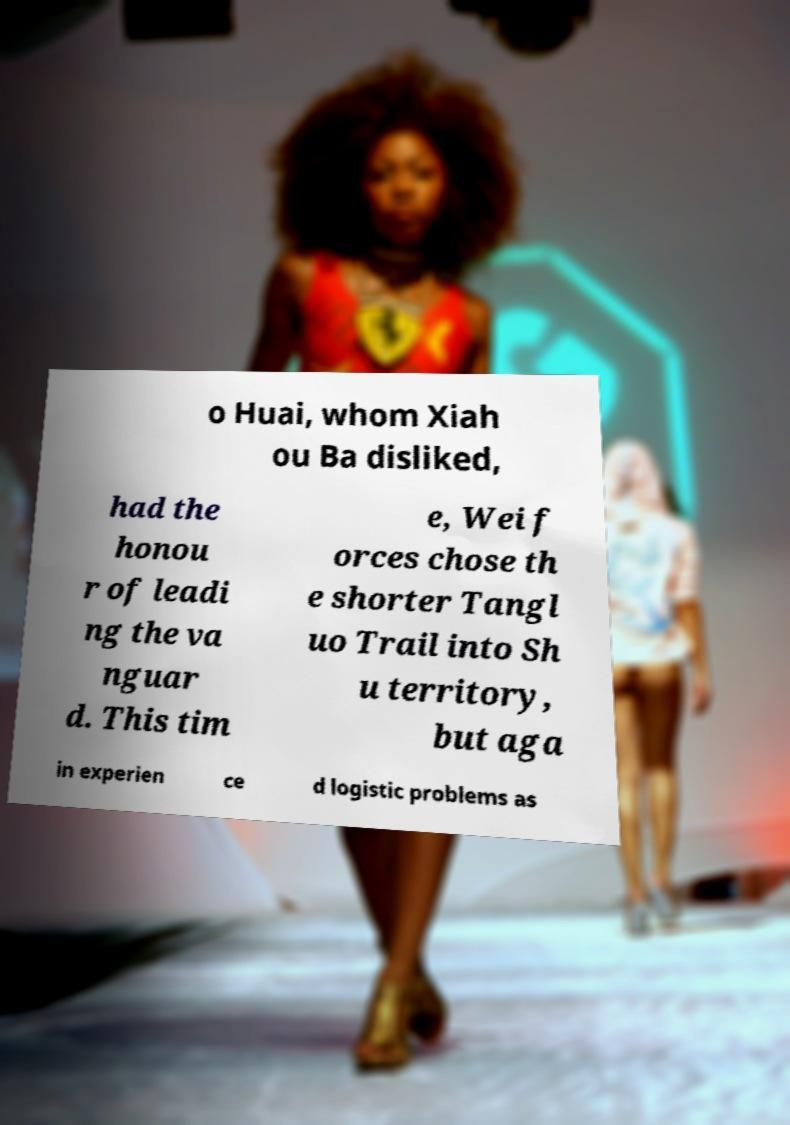Please read and relay the text visible in this image. What does it say? o Huai, whom Xiah ou Ba disliked, had the honou r of leadi ng the va nguar d. This tim e, Wei f orces chose th e shorter Tangl uo Trail into Sh u territory, but aga in experien ce d logistic problems as 